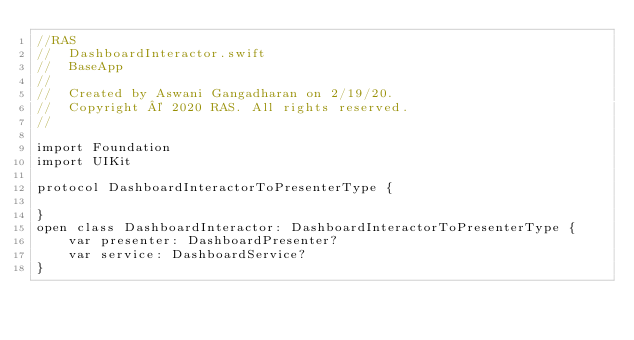<code> <loc_0><loc_0><loc_500><loc_500><_Swift_>//RAS
//  DashboardInteractor.swift
//  BaseApp
//
//  Created by Aswani Gangadharan on 2/19/20.
//  Copyright © 2020 RAS. All rights reserved.
//

import Foundation
import UIKit

protocol DashboardInteractorToPresenterType {
     
}
open class DashboardInteractor: DashboardInteractorToPresenterType {
    var presenter: DashboardPresenter?
    var service: DashboardService?
}
</code> 